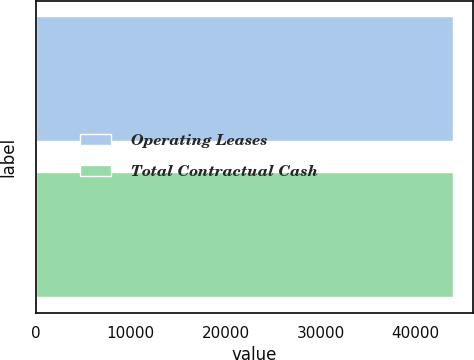Convert chart to OTSL. <chart><loc_0><loc_0><loc_500><loc_500><bar_chart><fcel>Operating Leases<fcel>Total Contractual Cash<nl><fcel>43921<fcel>43921.1<nl></chart> 